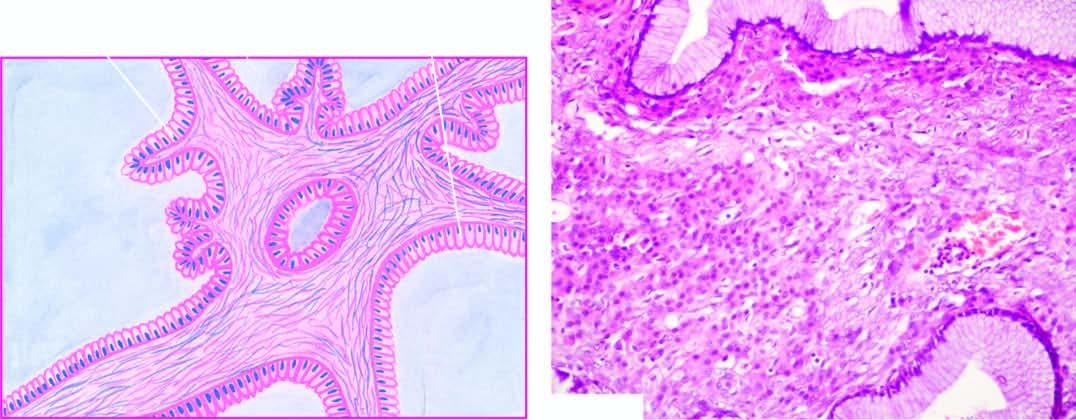re the cyst wall and the septa lined by a single layer of tall columnar mucin-secreting epithelium with basally-placed nuclei and large apical mucinous vacuoles?
Answer the question using a single word or phrase. Yes 